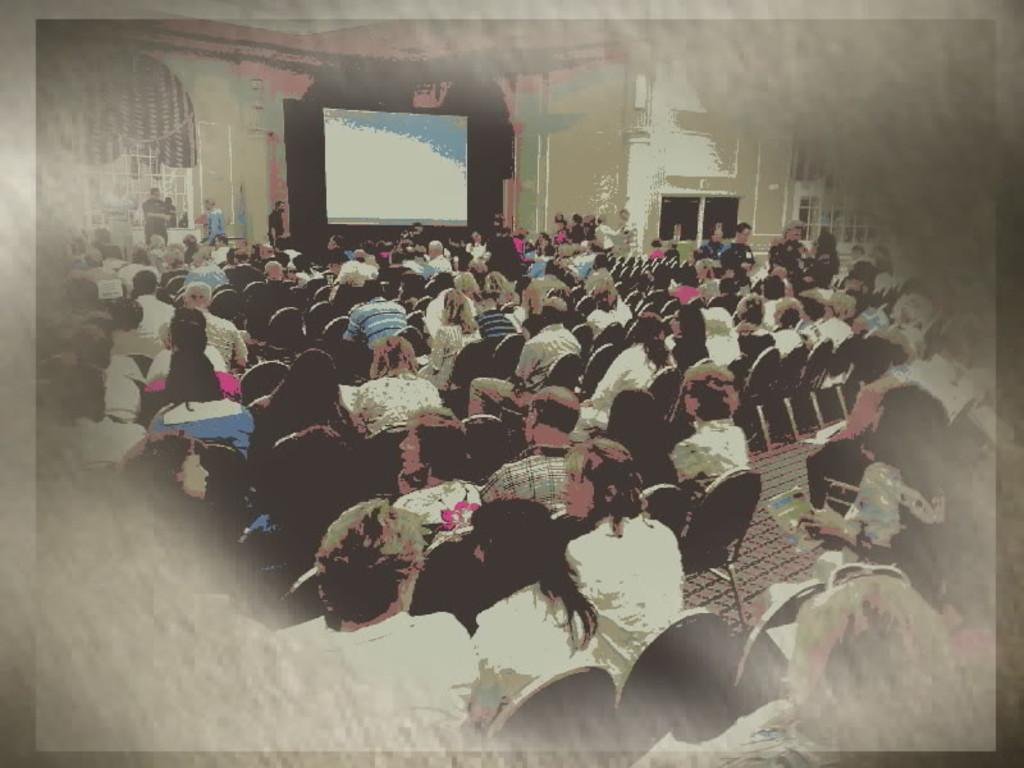What are the people in the image doing? The people in the image are sitting on chairs. How many people are in the image? There are people in the image, but the exact number is not specified, so we cannot provide a definitive answer. What can be seen in the background of the image? There are windows and a screen on the wall in the background of the image. We start by identifying the main subjects in the image, which are the people sitting on chairs. Then, we expand the conversation to include other details about the image, such as the presence of windows and a screen on the wall in the background. Each question is designed to elicit a specific detail about the image that is known from the provided facts. Absurd Question/Answer: What type of glove is being used by the person in the image? There is no glove present in the image. What color is the vest worn by the person in the image? There is no vest present in the image. What type of tin is being used by the person in the image? There is no tin present in the image. 